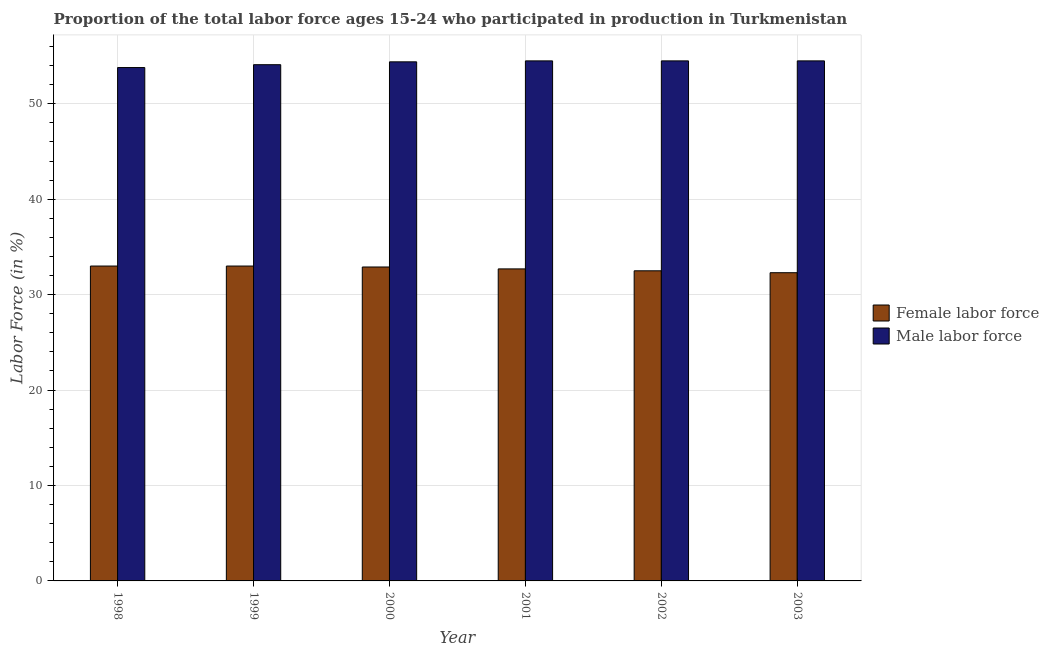How many groups of bars are there?
Offer a very short reply. 6. Are the number of bars per tick equal to the number of legend labels?
Ensure brevity in your answer.  Yes. Are the number of bars on each tick of the X-axis equal?
Your answer should be compact. Yes. How many bars are there on the 2nd tick from the right?
Offer a terse response. 2. What is the percentage of male labour force in 2000?
Ensure brevity in your answer.  54.4. Across all years, what is the maximum percentage of male labour force?
Offer a terse response. 54.5. Across all years, what is the minimum percentage of female labor force?
Offer a terse response. 32.3. In which year was the percentage of male labour force maximum?
Provide a succinct answer. 2001. In which year was the percentage of male labour force minimum?
Offer a terse response. 1998. What is the total percentage of female labor force in the graph?
Ensure brevity in your answer.  196.4. What is the difference between the percentage of male labour force in 1998 and that in 1999?
Provide a short and direct response. -0.3. What is the average percentage of male labour force per year?
Give a very brief answer. 54.3. What is the ratio of the percentage of male labour force in 1999 to that in 2003?
Your answer should be very brief. 0.99. Is the percentage of male labour force in 1998 less than that in 2001?
Offer a terse response. Yes. What is the difference between the highest and the lowest percentage of male labour force?
Your answer should be very brief. 0.7. In how many years, is the percentage of female labor force greater than the average percentage of female labor force taken over all years?
Provide a short and direct response. 3. Is the sum of the percentage of female labor force in 2001 and 2003 greater than the maximum percentage of male labour force across all years?
Offer a terse response. Yes. What does the 2nd bar from the left in 2002 represents?
Your answer should be compact. Male labor force. What does the 2nd bar from the right in 1999 represents?
Your answer should be very brief. Female labor force. How many bars are there?
Provide a succinct answer. 12. Are all the bars in the graph horizontal?
Keep it short and to the point. No. How many years are there in the graph?
Keep it short and to the point. 6. What is the difference between two consecutive major ticks on the Y-axis?
Keep it short and to the point. 10. Are the values on the major ticks of Y-axis written in scientific E-notation?
Your response must be concise. No. What is the title of the graph?
Make the answer very short. Proportion of the total labor force ages 15-24 who participated in production in Turkmenistan. What is the label or title of the X-axis?
Offer a very short reply. Year. What is the Labor Force (in %) of Male labor force in 1998?
Your answer should be very brief. 53.8. What is the Labor Force (in %) in Male labor force in 1999?
Make the answer very short. 54.1. What is the Labor Force (in %) of Female labor force in 2000?
Your answer should be very brief. 32.9. What is the Labor Force (in %) in Male labor force in 2000?
Your answer should be very brief. 54.4. What is the Labor Force (in %) of Female labor force in 2001?
Your response must be concise. 32.7. What is the Labor Force (in %) in Male labor force in 2001?
Keep it short and to the point. 54.5. What is the Labor Force (in %) of Female labor force in 2002?
Make the answer very short. 32.5. What is the Labor Force (in %) in Male labor force in 2002?
Offer a very short reply. 54.5. What is the Labor Force (in %) of Female labor force in 2003?
Make the answer very short. 32.3. What is the Labor Force (in %) of Male labor force in 2003?
Your answer should be compact. 54.5. Across all years, what is the maximum Labor Force (in %) in Male labor force?
Your response must be concise. 54.5. Across all years, what is the minimum Labor Force (in %) of Female labor force?
Your response must be concise. 32.3. Across all years, what is the minimum Labor Force (in %) of Male labor force?
Your answer should be very brief. 53.8. What is the total Labor Force (in %) of Female labor force in the graph?
Your answer should be compact. 196.4. What is the total Labor Force (in %) of Male labor force in the graph?
Provide a short and direct response. 325.8. What is the difference between the Labor Force (in %) of Female labor force in 1998 and that in 1999?
Your response must be concise. 0. What is the difference between the Labor Force (in %) in Male labor force in 1998 and that in 1999?
Your answer should be compact. -0.3. What is the difference between the Labor Force (in %) in Female labor force in 1998 and that in 2000?
Your response must be concise. 0.1. What is the difference between the Labor Force (in %) of Female labor force in 1998 and that in 2001?
Make the answer very short. 0.3. What is the difference between the Labor Force (in %) in Male labor force in 1998 and that in 2001?
Offer a terse response. -0.7. What is the difference between the Labor Force (in %) of Female labor force in 1998 and that in 2002?
Provide a short and direct response. 0.5. What is the difference between the Labor Force (in %) in Female labor force in 1998 and that in 2003?
Keep it short and to the point. 0.7. What is the difference between the Labor Force (in %) of Female labor force in 1999 and that in 2002?
Keep it short and to the point. 0.5. What is the difference between the Labor Force (in %) of Male labor force in 1999 and that in 2003?
Provide a short and direct response. -0.4. What is the difference between the Labor Force (in %) of Female labor force in 2000 and that in 2001?
Give a very brief answer. 0.2. What is the difference between the Labor Force (in %) of Male labor force in 2000 and that in 2001?
Your answer should be very brief. -0.1. What is the difference between the Labor Force (in %) of Female labor force in 2000 and that in 2002?
Give a very brief answer. 0.4. What is the difference between the Labor Force (in %) of Female labor force in 2001 and that in 2003?
Your answer should be very brief. 0.4. What is the difference between the Labor Force (in %) of Female labor force in 2002 and that in 2003?
Offer a terse response. 0.2. What is the difference between the Labor Force (in %) in Male labor force in 2002 and that in 2003?
Give a very brief answer. 0. What is the difference between the Labor Force (in %) of Female labor force in 1998 and the Labor Force (in %) of Male labor force in 1999?
Make the answer very short. -21.1. What is the difference between the Labor Force (in %) of Female labor force in 1998 and the Labor Force (in %) of Male labor force in 2000?
Offer a very short reply. -21.4. What is the difference between the Labor Force (in %) of Female labor force in 1998 and the Labor Force (in %) of Male labor force in 2001?
Your answer should be very brief. -21.5. What is the difference between the Labor Force (in %) of Female labor force in 1998 and the Labor Force (in %) of Male labor force in 2002?
Keep it short and to the point. -21.5. What is the difference between the Labor Force (in %) of Female labor force in 1998 and the Labor Force (in %) of Male labor force in 2003?
Make the answer very short. -21.5. What is the difference between the Labor Force (in %) in Female labor force in 1999 and the Labor Force (in %) in Male labor force in 2000?
Your response must be concise. -21.4. What is the difference between the Labor Force (in %) in Female labor force in 1999 and the Labor Force (in %) in Male labor force in 2001?
Ensure brevity in your answer.  -21.5. What is the difference between the Labor Force (in %) in Female labor force in 1999 and the Labor Force (in %) in Male labor force in 2002?
Provide a succinct answer. -21.5. What is the difference between the Labor Force (in %) in Female labor force in 1999 and the Labor Force (in %) in Male labor force in 2003?
Give a very brief answer. -21.5. What is the difference between the Labor Force (in %) of Female labor force in 2000 and the Labor Force (in %) of Male labor force in 2001?
Offer a very short reply. -21.6. What is the difference between the Labor Force (in %) of Female labor force in 2000 and the Labor Force (in %) of Male labor force in 2002?
Provide a short and direct response. -21.6. What is the difference between the Labor Force (in %) of Female labor force in 2000 and the Labor Force (in %) of Male labor force in 2003?
Your answer should be very brief. -21.6. What is the difference between the Labor Force (in %) in Female labor force in 2001 and the Labor Force (in %) in Male labor force in 2002?
Ensure brevity in your answer.  -21.8. What is the difference between the Labor Force (in %) in Female labor force in 2001 and the Labor Force (in %) in Male labor force in 2003?
Offer a very short reply. -21.8. What is the average Labor Force (in %) in Female labor force per year?
Keep it short and to the point. 32.73. What is the average Labor Force (in %) of Male labor force per year?
Offer a very short reply. 54.3. In the year 1998, what is the difference between the Labor Force (in %) of Female labor force and Labor Force (in %) of Male labor force?
Your response must be concise. -20.8. In the year 1999, what is the difference between the Labor Force (in %) in Female labor force and Labor Force (in %) in Male labor force?
Provide a succinct answer. -21.1. In the year 2000, what is the difference between the Labor Force (in %) in Female labor force and Labor Force (in %) in Male labor force?
Your answer should be compact. -21.5. In the year 2001, what is the difference between the Labor Force (in %) in Female labor force and Labor Force (in %) in Male labor force?
Your answer should be very brief. -21.8. In the year 2002, what is the difference between the Labor Force (in %) of Female labor force and Labor Force (in %) of Male labor force?
Offer a terse response. -22. In the year 2003, what is the difference between the Labor Force (in %) in Female labor force and Labor Force (in %) in Male labor force?
Offer a terse response. -22.2. What is the ratio of the Labor Force (in %) of Female labor force in 1998 to that in 1999?
Make the answer very short. 1. What is the ratio of the Labor Force (in %) of Male labor force in 1998 to that in 1999?
Provide a succinct answer. 0.99. What is the ratio of the Labor Force (in %) in Female labor force in 1998 to that in 2000?
Give a very brief answer. 1. What is the ratio of the Labor Force (in %) in Female labor force in 1998 to that in 2001?
Ensure brevity in your answer.  1.01. What is the ratio of the Labor Force (in %) of Male labor force in 1998 to that in 2001?
Provide a short and direct response. 0.99. What is the ratio of the Labor Force (in %) in Female labor force in 1998 to that in 2002?
Give a very brief answer. 1.02. What is the ratio of the Labor Force (in %) of Male labor force in 1998 to that in 2002?
Make the answer very short. 0.99. What is the ratio of the Labor Force (in %) in Female labor force in 1998 to that in 2003?
Ensure brevity in your answer.  1.02. What is the ratio of the Labor Force (in %) of Male labor force in 1998 to that in 2003?
Offer a very short reply. 0.99. What is the ratio of the Labor Force (in %) in Female labor force in 1999 to that in 2000?
Ensure brevity in your answer.  1. What is the ratio of the Labor Force (in %) in Female labor force in 1999 to that in 2001?
Offer a very short reply. 1.01. What is the ratio of the Labor Force (in %) of Female labor force in 1999 to that in 2002?
Your answer should be compact. 1.02. What is the ratio of the Labor Force (in %) of Male labor force in 1999 to that in 2002?
Your answer should be very brief. 0.99. What is the ratio of the Labor Force (in %) in Female labor force in 1999 to that in 2003?
Offer a terse response. 1.02. What is the ratio of the Labor Force (in %) of Male labor force in 1999 to that in 2003?
Offer a very short reply. 0.99. What is the ratio of the Labor Force (in %) in Female labor force in 2000 to that in 2001?
Provide a succinct answer. 1.01. What is the ratio of the Labor Force (in %) of Male labor force in 2000 to that in 2001?
Keep it short and to the point. 1. What is the ratio of the Labor Force (in %) of Female labor force in 2000 to that in 2002?
Ensure brevity in your answer.  1.01. What is the ratio of the Labor Force (in %) of Female labor force in 2000 to that in 2003?
Make the answer very short. 1.02. What is the ratio of the Labor Force (in %) in Female labor force in 2001 to that in 2002?
Offer a very short reply. 1.01. What is the ratio of the Labor Force (in %) in Female labor force in 2001 to that in 2003?
Your response must be concise. 1.01. What is the ratio of the Labor Force (in %) in Male labor force in 2001 to that in 2003?
Give a very brief answer. 1. What is the ratio of the Labor Force (in %) in Male labor force in 2002 to that in 2003?
Your answer should be compact. 1. What is the difference between the highest and the lowest Labor Force (in %) of Male labor force?
Offer a very short reply. 0.7. 